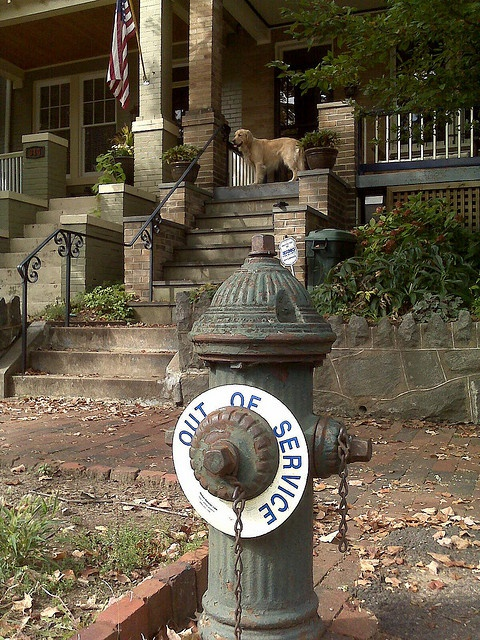Describe the objects in this image and their specific colors. I can see fire hydrant in darkgreen, gray, black, white, and darkgray tones and dog in darkgreen, gray, and tan tones in this image. 